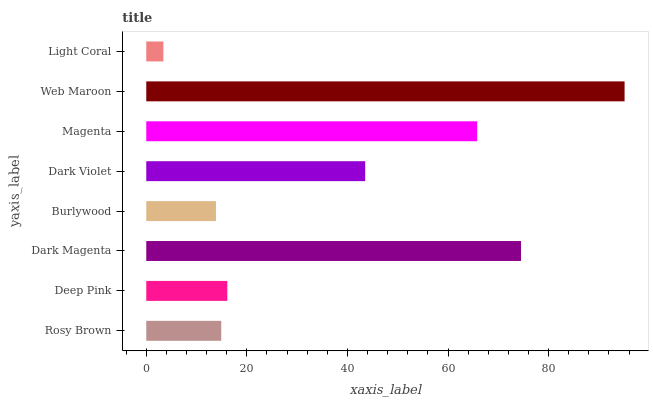Is Light Coral the minimum?
Answer yes or no. Yes. Is Web Maroon the maximum?
Answer yes or no. Yes. Is Deep Pink the minimum?
Answer yes or no. No. Is Deep Pink the maximum?
Answer yes or no. No. Is Deep Pink greater than Rosy Brown?
Answer yes or no. Yes. Is Rosy Brown less than Deep Pink?
Answer yes or no. Yes. Is Rosy Brown greater than Deep Pink?
Answer yes or no. No. Is Deep Pink less than Rosy Brown?
Answer yes or no. No. Is Dark Violet the high median?
Answer yes or no. Yes. Is Deep Pink the low median?
Answer yes or no. Yes. Is Burlywood the high median?
Answer yes or no. No. Is Web Maroon the low median?
Answer yes or no. No. 